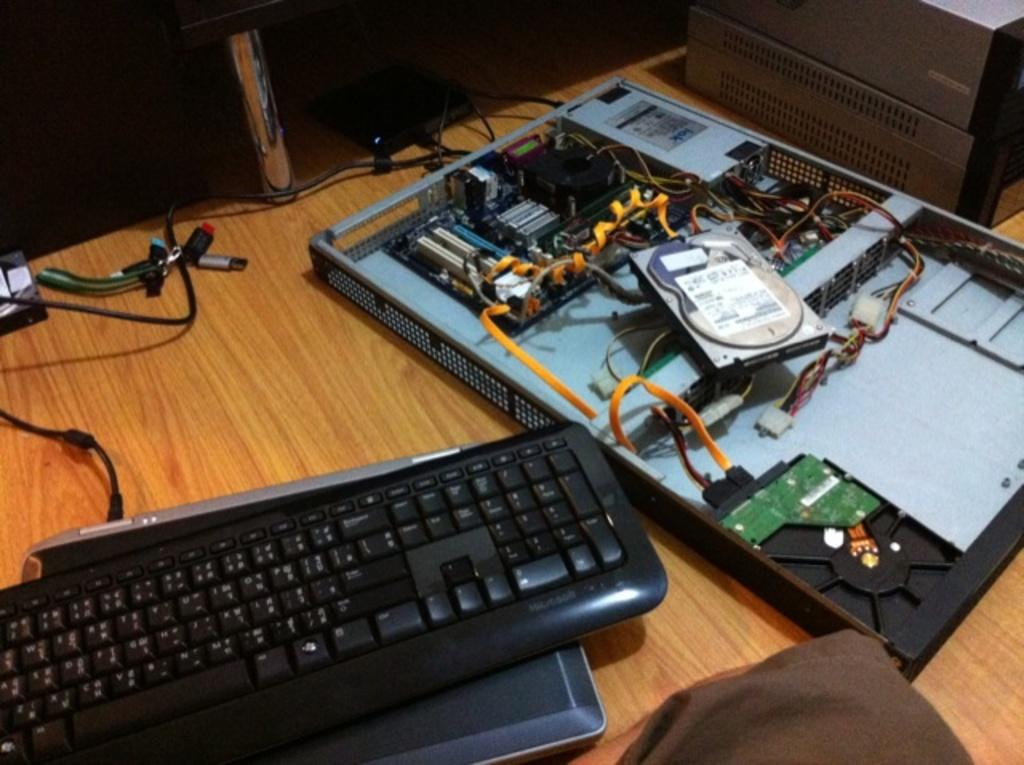What type of furniture is present in the image? There is a table in the image. What is placed on the table? There is a keyboard on the table. What other items can be seen in the image? There are electronic items with connectors and wires in the image. How does the uncle interact with the sleet in the image? There is no uncle or sleet present in the image. 